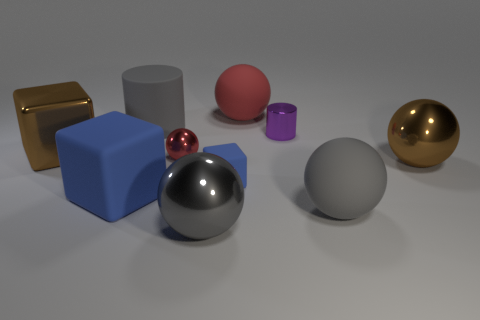Subtract all blue blocks. How many blocks are left? 1 Subtract all gray cylinders. How many cylinders are left? 1 Subtract all cylinders. How many objects are left? 8 Subtract all tiny red spheres. Subtract all small purple cylinders. How many objects are left? 8 Add 4 brown metal objects. How many brown metal objects are left? 6 Add 2 tiny cyan balls. How many tiny cyan balls exist? 2 Subtract 2 blue cubes. How many objects are left? 8 Subtract 2 blocks. How many blocks are left? 1 Subtract all brown cylinders. Subtract all purple spheres. How many cylinders are left? 2 Subtract all yellow balls. How many cyan blocks are left? 0 